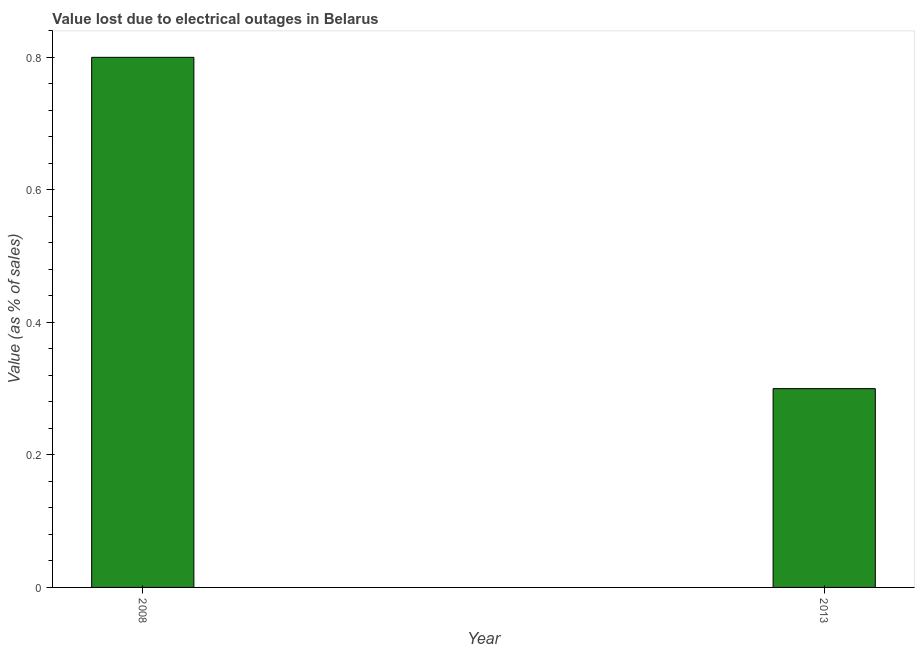Does the graph contain any zero values?
Give a very brief answer. No. What is the title of the graph?
Give a very brief answer. Value lost due to electrical outages in Belarus. What is the label or title of the X-axis?
Give a very brief answer. Year. What is the label or title of the Y-axis?
Provide a succinct answer. Value (as % of sales). What is the value lost due to electrical outages in 2013?
Ensure brevity in your answer.  0.3. Across all years, what is the minimum value lost due to electrical outages?
Provide a short and direct response. 0.3. In which year was the value lost due to electrical outages maximum?
Ensure brevity in your answer.  2008. What is the average value lost due to electrical outages per year?
Your response must be concise. 0.55. What is the median value lost due to electrical outages?
Offer a terse response. 0.55. In how many years, is the value lost due to electrical outages greater than 0.36 %?
Offer a very short reply. 1. Do a majority of the years between 2008 and 2013 (inclusive) have value lost due to electrical outages greater than 0.56 %?
Keep it short and to the point. No. What is the ratio of the value lost due to electrical outages in 2008 to that in 2013?
Offer a very short reply. 2.67. Is the value lost due to electrical outages in 2008 less than that in 2013?
Give a very brief answer. No. In how many years, is the value lost due to electrical outages greater than the average value lost due to electrical outages taken over all years?
Your answer should be very brief. 1. How many bars are there?
Provide a succinct answer. 2. How many years are there in the graph?
Make the answer very short. 2. What is the difference between two consecutive major ticks on the Y-axis?
Keep it short and to the point. 0.2. Are the values on the major ticks of Y-axis written in scientific E-notation?
Your answer should be compact. No. What is the Value (as % of sales) of 2008?
Provide a short and direct response. 0.8. What is the difference between the Value (as % of sales) in 2008 and 2013?
Give a very brief answer. 0.5. What is the ratio of the Value (as % of sales) in 2008 to that in 2013?
Provide a short and direct response. 2.67. 